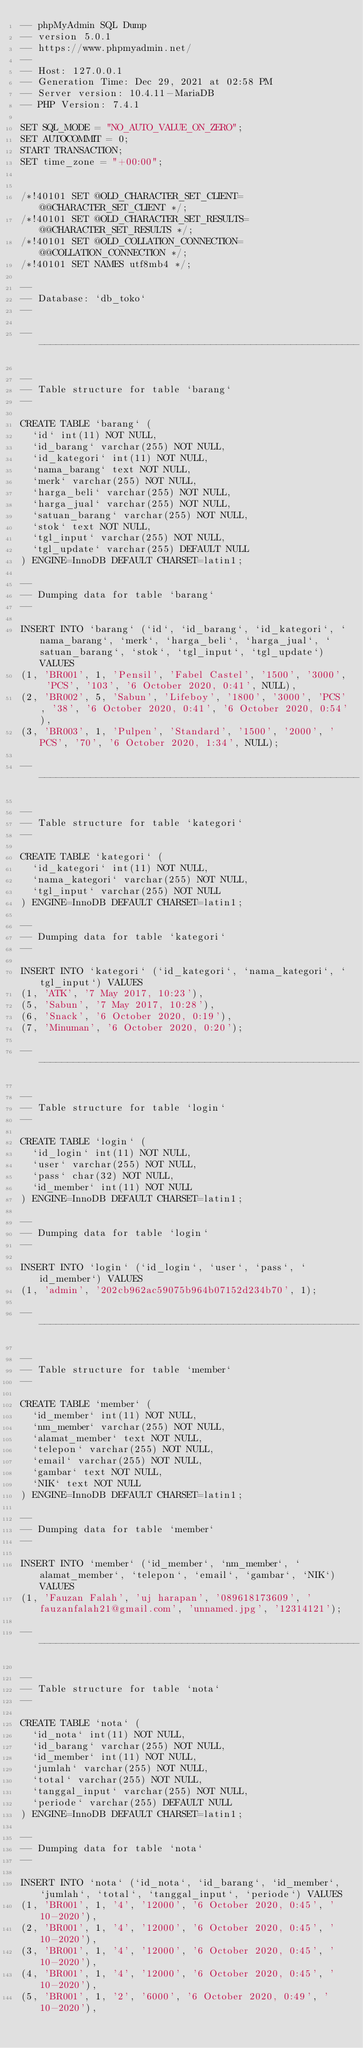Convert code to text. <code><loc_0><loc_0><loc_500><loc_500><_SQL_>-- phpMyAdmin SQL Dump
-- version 5.0.1
-- https://www.phpmyadmin.net/
--
-- Host: 127.0.0.1
-- Generation Time: Dec 29, 2021 at 02:58 PM
-- Server version: 10.4.11-MariaDB
-- PHP Version: 7.4.1

SET SQL_MODE = "NO_AUTO_VALUE_ON_ZERO";
SET AUTOCOMMIT = 0;
START TRANSACTION;
SET time_zone = "+00:00";


/*!40101 SET @OLD_CHARACTER_SET_CLIENT=@@CHARACTER_SET_CLIENT */;
/*!40101 SET @OLD_CHARACTER_SET_RESULTS=@@CHARACTER_SET_RESULTS */;
/*!40101 SET @OLD_COLLATION_CONNECTION=@@COLLATION_CONNECTION */;
/*!40101 SET NAMES utf8mb4 */;

--
-- Database: `db_toko`
--

-- --------------------------------------------------------

--
-- Table structure for table `barang`
--

CREATE TABLE `barang` (
  `id` int(11) NOT NULL,
  `id_barang` varchar(255) NOT NULL,
  `id_kategori` int(11) NOT NULL,
  `nama_barang` text NOT NULL,
  `merk` varchar(255) NOT NULL,
  `harga_beli` varchar(255) NOT NULL,
  `harga_jual` varchar(255) NOT NULL,
  `satuan_barang` varchar(255) NOT NULL,
  `stok` text NOT NULL,
  `tgl_input` varchar(255) NOT NULL,
  `tgl_update` varchar(255) DEFAULT NULL
) ENGINE=InnoDB DEFAULT CHARSET=latin1;

--
-- Dumping data for table `barang`
--

INSERT INTO `barang` (`id`, `id_barang`, `id_kategori`, `nama_barang`, `merk`, `harga_beli`, `harga_jual`, `satuan_barang`, `stok`, `tgl_input`, `tgl_update`) VALUES
(1, 'BR001', 1, 'Pensil', 'Fabel Castel', '1500', '3000', 'PCS', '103', '6 October 2020, 0:41', NULL),
(2, 'BR002', 5, 'Sabun', 'Lifeboy', '1800', '3000', 'PCS', '38', '6 October 2020, 0:41', '6 October 2020, 0:54'),
(3, 'BR003', 1, 'Pulpen', 'Standard', '1500', '2000', 'PCS', '70', '6 October 2020, 1:34', NULL);

-- --------------------------------------------------------

--
-- Table structure for table `kategori`
--

CREATE TABLE `kategori` (
  `id_kategori` int(11) NOT NULL,
  `nama_kategori` varchar(255) NOT NULL,
  `tgl_input` varchar(255) NOT NULL
) ENGINE=InnoDB DEFAULT CHARSET=latin1;

--
-- Dumping data for table `kategori`
--

INSERT INTO `kategori` (`id_kategori`, `nama_kategori`, `tgl_input`) VALUES
(1, 'ATK', '7 May 2017, 10:23'),
(5, 'Sabun', '7 May 2017, 10:28'),
(6, 'Snack', '6 October 2020, 0:19'),
(7, 'Minuman', '6 October 2020, 0:20');

-- --------------------------------------------------------

--
-- Table structure for table `login`
--

CREATE TABLE `login` (
  `id_login` int(11) NOT NULL,
  `user` varchar(255) NOT NULL,
  `pass` char(32) NOT NULL,
  `id_member` int(11) NOT NULL
) ENGINE=InnoDB DEFAULT CHARSET=latin1;

--
-- Dumping data for table `login`
--

INSERT INTO `login` (`id_login`, `user`, `pass`, `id_member`) VALUES
(1, 'admin', '202cb962ac59075b964b07152d234b70', 1);

-- --------------------------------------------------------

--
-- Table structure for table `member`
--

CREATE TABLE `member` (
  `id_member` int(11) NOT NULL,
  `nm_member` varchar(255) NOT NULL,
  `alamat_member` text NOT NULL,
  `telepon` varchar(255) NOT NULL,
  `email` varchar(255) NOT NULL,
  `gambar` text NOT NULL,
  `NIK` text NOT NULL
) ENGINE=InnoDB DEFAULT CHARSET=latin1;

--
-- Dumping data for table `member`
--

INSERT INTO `member` (`id_member`, `nm_member`, `alamat_member`, `telepon`, `email`, `gambar`, `NIK`) VALUES
(1, 'Fauzan Falah', 'uj harapan', '089618173609', 'fauzanfalah21@gmail.com', 'unnamed.jpg', '12314121');

-- --------------------------------------------------------

--
-- Table structure for table `nota`
--

CREATE TABLE `nota` (
  `id_nota` int(11) NOT NULL,
  `id_barang` varchar(255) NOT NULL,
  `id_member` int(11) NOT NULL,
  `jumlah` varchar(255) NOT NULL,
  `total` varchar(255) NOT NULL,
  `tanggal_input` varchar(255) NOT NULL,
  `periode` varchar(255) DEFAULT NULL
) ENGINE=InnoDB DEFAULT CHARSET=latin1;

--
-- Dumping data for table `nota`
--

INSERT INTO `nota` (`id_nota`, `id_barang`, `id_member`, `jumlah`, `total`, `tanggal_input`, `periode`) VALUES
(1, 'BR001', 1, '4', '12000', '6 October 2020, 0:45', '10-2020'),
(2, 'BR001', 1, '4', '12000', '6 October 2020, 0:45', '10-2020'),
(3, 'BR001', 1, '4', '12000', '6 October 2020, 0:45', '10-2020'),
(4, 'BR001', 1, '4', '12000', '6 October 2020, 0:45', '10-2020'),
(5, 'BR001', 1, '2', '6000', '6 October 2020, 0:49', '10-2020'),</code> 